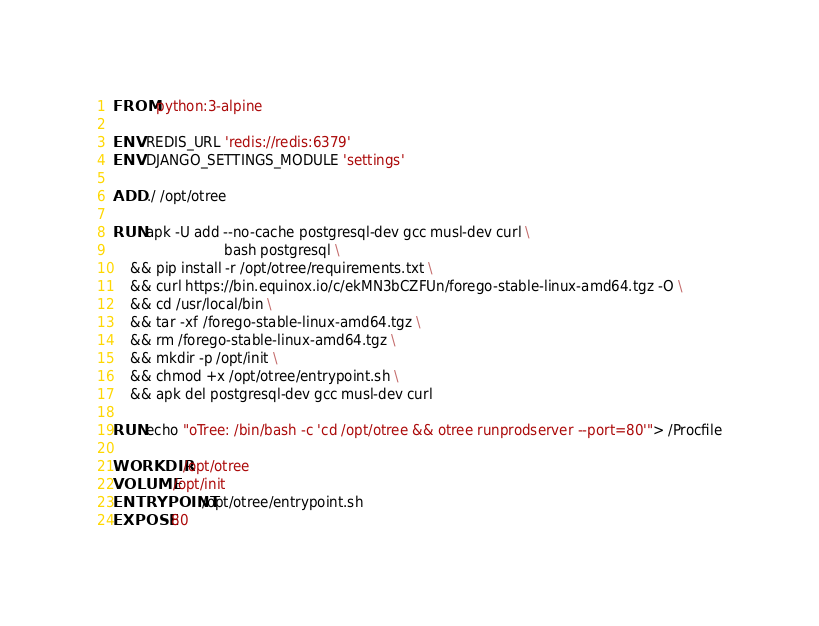Convert code to text. <code><loc_0><loc_0><loc_500><loc_500><_Dockerfile_>FROM python:3-alpine

ENV REDIS_URL 'redis://redis:6379'
ENV DJANGO_SETTINGS_MODULE 'settings'

ADD ./ /opt/otree

RUN apk -U add --no-cache postgresql-dev gcc musl-dev curl \
                          bash postgresql \
    && pip install -r /opt/otree/requirements.txt \
    && curl https://bin.equinox.io/c/ekMN3bCZFUn/forego-stable-linux-amd64.tgz -O \
	&& cd /usr/local/bin \
	&& tar -xf /forego-stable-linux-amd64.tgz \
	&& rm /forego-stable-linux-amd64.tgz \
    && mkdir -p /opt/init \
    && chmod +x /opt/otree/entrypoint.sh \
    && apk del postgresql-dev gcc musl-dev curl

RUN echo "oTree: /bin/bash -c 'cd /opt/otree && otree runprodserver --port=80'"> /Procfile

WORKDIR /opt/otree
VOLUME /opt/init
ENTRYPOINT /opt/otree/entrypoint.sh
EXPOSE 80
</code> 